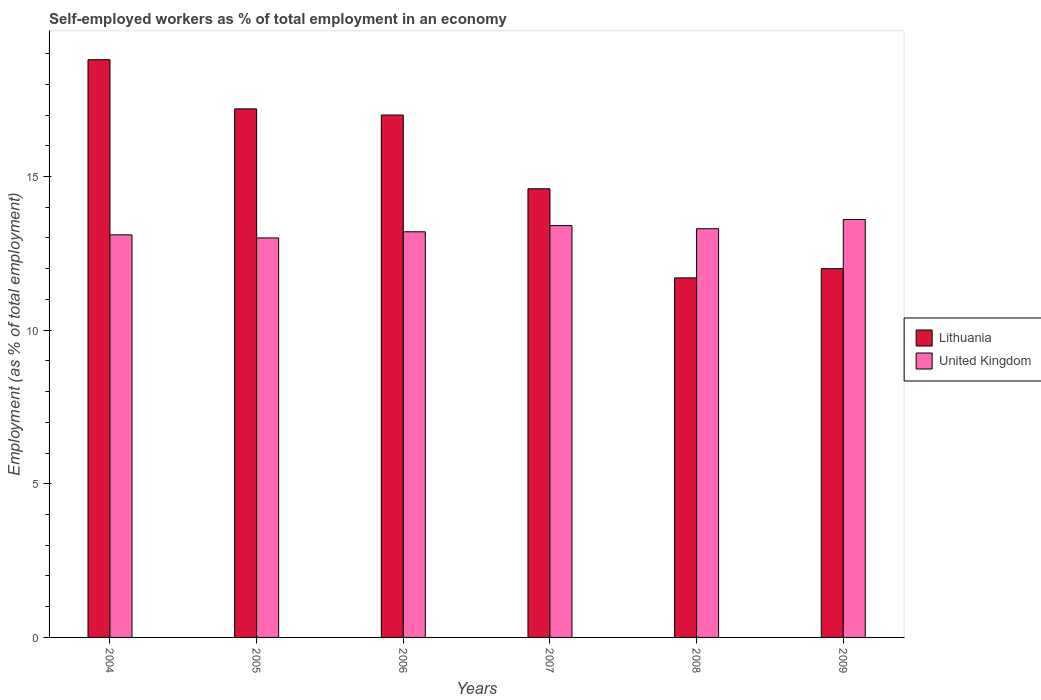How many different coloured bars are there?
Your answer should be compact. 2. How many groups of bars are there?
Offer a terse response. 6. Are the number of bars per tick equal to the number of legend labels?
Your response must be concise. Yes. Are the number of bars on each tick of the X-axis equal?
Offer a terse response. Yes. How many bars are there on the 4th tick from the right?
Your answer should be very brief. 2. What is the label of the 2nd group of bars from the left?
Keep it short and to the point. 2005. In how many cases, is the number of bars for a given year not equal to the number of legend labels?
Provide a short and direct response. 0. What is the percentage of self-employed workers in United Kingdom in 2005?
Ensure brevity in your answer.  13. Across all years, what is the maximum percentage of self-employed workers in Lithuania?
Give a very brief answer. 18.8. Across all years, what is the minimum percentage of self-employed workers in Lithuania?
Your response must be concise. 11.7. In which year was the percentage of self-employed workers in Lithuania maximum?
Give a very brief answer. 2004. What is the total percentage of self-employed workers in Lithuania in the graph?
Offer a very short reply. 91.3. What is the difference between the percentage of self-employed workers in Lithuania in 2005 and that in 2008?
Make the answer very short. 5.5. What is the difference between the percentage of self-employed workers in Lithuania in 2006 and the percentage of self-employed workers in United Kingdom in 2004?
Your answer should be compact. 3.9. What is the average percentage of self-employed workers in Lithuania per year?
Offer a very short reply. 15.22. In the year 2006, what is the difference between the percentage of self-employed workers in Lithuania and percentage of self-employed workers in United Kingdom?
Make the answer very short. 3.8. What is the ratio of the percentage of self-employed workers in Lithuania in 2004 to that in 2007?
Provide a short and direct response. 1.29. What is the difference between the highest and the second highest percentage of self-employed workers in Lithuania?
Offer a terse response. 1.6. What is the difference between the highest and the lowest percentage of self-employed workers in United Kingdom?
Provide a succinct answer. 0.6. In how many years, is the percentage of self-employed workers in United Kingdom greater than the average percentage of self-employed workers in United Kingdom taken over all years?
Your answer should be compact. 3. What does the 1st bar from the left in 2008 represents?
Your answer should be compact. Lithuania. What does the 1st bar from the right in 2009 represents?
Keep it short and to the point. United Kingdom. How many bars are there?
Offer a terse response. 12. Are the values on the major ticks of Y-axis written in scientific E-notation?
Provide a succinct answer. No. Does the graph contain any zero values?
Provide a succinct answer. No. How many legend labels are there?
Offer a terse response. 2. How are the legend labels stacked?
Offer a very short reply. Vertical. What is the title of the graph?
Make the answer very short. Self-employed workers as % of total employment in an economy. What is the label or title of the X-axis?
Offer a very short reply. Years. What is the label or title of the Y-axis?
Ensure brevity in your answer.  Employment (as % of total employment). What is the Employment (as % of total employment) of Lithuania in 2004?
Your answer should be very brief. 18.8. What is the Employment (as % of total employment) in United Kingdom in 2004?
Make the answer very short. 13.1. What is the Employment (as % of total employment) of Lithuania in 2005?
Make the answer very short. 17.2. What is the Employment (as % of total employment) in United Kingdom in 2005?
Keep it short and to the point. 13. What is the Employment (as % of total employment) in United Kingdom in 2006?
Your answer should be very brief. 13.2. What is the Employment (as % of total employment) in Lithuania in 2007?
Give a very brief answer. 14.6. What is the Employment (as % of total employment) of United Kingdom in 2007?
Offer a terse response. 13.4. What is the Employment (as % of total employment) in Lithuania in 2008?
Offer a very short reply. 11.7. What is the Employment (as % of total employment) in United Kingdom in 2008?
Your response must be concise. 13.3. What is the Employment (as % of total employment) of United Kingdom in 2009?
Your answer should be compact. 13.6. Across all years, what is the maximum Employment (as % of total employment) of Lithuania?
Offer a terse response. 18.8. Across all years, what is the maximum Employment (as % of total employment) in United Kingdom?
Offer a terse response. 13.6. Across all years, what is the minimum Employment (as % of total employment) in Lithuania?
Provide a succinct answer. 11.7. Across all years, what is the minimum Employment (as % of total employment) of United Kingdom?
Offer a terse response. 13. What is the total Employment (as % of total employment) in Lithuania in the graph?
Offer a very short reply. 91.3. What is the total Employment (as % of total employment) in United Kingdom in the graph?
Your response must be concise. 79.6. What is the difference between the Employment (as % of total employment) in United Kingdom in 2004 and that in 2005?
Provide a succinct answer. 0.1. What is the difference between the Employment (as % of total employment) in United Kingdom in 2004 and that in 2006?
Your answer should be very brief. -0.1. What is the difference between the Employment (as % of total employment) of United Kingdom in 2004 and that in 2007?
Provide a short and direct response. -0.3. What is the difference between the Employment (as % of total employment) of United Kingdom in 2004 and that in 2009?
Provide a succinct answer. -0.5. What is the difference between the Employment (as % of total employment) in Lithuania in 2005 and that in 2006?
Offer a very short reply. 0.2. What is the difference between the Employment (as % of total employment) in Lithuania in 2005 and that in 2007?
Make the answer very short. 2.6. What is the difference between the Employment (as % of total employment) of United Kingdom in 2005 and that in 2007?
Provide a succinct answer. -0.4. What is the difference between the Employment (as % of total employment) of United Kingdom in 2005 and that in 2008?
Offer a very short reply. -0.3. What is the difference between the Employment (as % of total employment) of United Kingdom in 2005 and that in 2009?
Offer a terse response. -0.6. What is the difference between the Employment (as % of total employment) in Lithuania in 2006 and that in 2007?
Keep it short and to the point. 2.4. What is the difference between the Employment (as % of total employment) of Lithuania in 2006 and that in 2009?
Your answer should be very brief. 5. What is the difference between the Employment (as % of total employment) of United Kingdom in 2006 and that in 2009?
Offer a very short reply. -0.4. What is the difference between the Employment (as % of total employment) in Lithuania in 2007 and that in 2008?
Provide a short and direct response. 2.9. What is the difference between the Employment (as % of total employment) in United Kingdom in 2007 and that in 2008?
Offer a terse response. 0.1. What is the difference between the Employment (as % of total employment) in United Kingdom in 2007 and that in 2009?
Keep it short and to the point. -0.2. What is the difference between the Employment (as % of total employment) in Lithuania in 2008 and that in 2009?
Make the answer very short. -0.3. What is the difference between the Employment (as % of total employment) of United Kingdom in 2008 and that in 2009?
Your response must be concise. -0.3. What is the difference between the Employment (as % of total employment) in Lithuania in 2004 and the Employment (as % of total employment) in United Kingdom in 2005?
Make the answer very short. 5.8. What is the difference between the Employment (as % of total employment) of Lithuania in 2004 and the Employment (as % of total employment) of United Kingdom in 2006?
Offer a very short reply. 5.6. What is the difference between the Employment (as % of total employment) of Lithuania in 2004 and the Employment (as % of total employment) of United Kingdom in 2007?
Your answer should be very brief. 5.4. What is the difference between the Employment (as % of total employment) in Lithuania in 2004 and the Employment (as % of total employment) in United Kingdom in 2008?
Offer a very short reply. 5.5. What is the difference between the Employment (as % of total employment) in Lithuania in 2005 and the Employment (as % of total employment) in United Kingdom in 2006?
Provide a succinct answer. 4. What is the difference between the Employment (as % of total employment) of Lithuania in 2005 and the Employment (as % of total employment) of United Kingdom in 2009?
Ensure brevity in your answer.  3.6. What is the difference between the Employment (as % of total employment) in Lithuania in 2006 and the Employment (as % of total employment) in United Kingdom in 2008?
Make the answer very short. 3.7. What is the difference between the Employment (as % of total employment) of Lithuania in 2008 and the Employment (as % of total employment) of United Kingdom in 2009?
Make the answer very short. -1.9. What is the average Employment (as % of total employment) in Lithuania per year?
Your answer should be very brief. 15.22. What is the average Employment (as % of total employment) of United Kingdom per year?
Your answer should be compact. 13.27. In the year 2004, what is the difference between the Employment (as % of total employment) in Lithuania and Employment (as % of total employment) in United Kingdom?
Give a very brief answer. 5.7. In the year 2005, what is the difference between the Employment (as % of total employment) of Lithuania and Employment (as % of total employment) of United Kingdom?
Ensure brevity in your answer.  4.2. In the year 2006, what is the difference between the Employment (as % of total employment) in Lithuania and Employment (as % of total employment) in United Kingdom?
Your answer should be compact. 3.8. In the year 2008, what is the difference between the Employment (as % of total employment) in Lithuania and Employment (as % of total employment) in United Kingdom?
Your answer should be compact. -1.6. In the year 2009, what is the difference between the Employment (as % of total employment) of Lithuania and Employment (as % of total employment) of United Kingdom?
Your response must be concise. -1.6. What is the ratio of the Employment (as % of total employment) in Lithuania in 2004 to that in 2005?
Give a very brief answer. 1.09. What is the ratio of the Employment (as % of total employment) of United Kingdom in 2004 to that in 2005?
Provide a short and direct response. 1.01. What is the ratio of the Employment (as % of total employment) of Lithuania in 2004 to that in 2006?
Give a very brief answer. 1.11. What is the ratio of the Employment (as % of total employment) of United Kingdom in 2004 to that in 2006?
Provide a short and direct response. 0.99. What is the ratio of the Employment (as % of total employment) in Lithuania in 2004 to that in 2007?
Your response must be concise. 1.29. What is the ratio of the Employment (as % of total employment) of United Kingdom in 2004 to that in 2007?
Provide a succinct answer. 0.98. What is the ratio of the Employment (as % of total employment) in Lithuania in 2004 to that in 2008?
Provide a succinct answer. 1.61. What is the ratio of the Employment (as % of total employment) in Lithuania in 2004 to that in 2009?
Give a very brief answer. 1.57. What is the ratio of the Employment (as % of total employment) of United Kingdom in 2004 to that in 2009?
Keep it short and to the point. 0.96. What is the ratio of the Employment (as % of total employment) in Lithuania in 2005 to that in 2006?
Offer a very short reply. 1.01. What is the ratio of the Employment (as % of total employment) of United Kingdom in 2005 to that in 2006?
Your answer should be compact. 0.98. What is the ratio of the Employment (as % of total employment) in Lithuania in 2005 to that in 2007?
Offer a terse response. 1.18. What is the ratio of the Employment (as % of total employment) of United Kingdom in 2005 to that in 2007?
Offer a very short reply. 0.97. What is the ratio of the Employment (as % of total employment) of Lithuania in 2005 to that in 2008?
Offer a terse response. 1.47. What is the ratio of the Employment (as % of total employment) in United Kingdom in 2005 to that in 2008?
Keep it short and to the point. 0.98. What is the ratio of the Employment (as % of total employment) in Lithuania in 2005 to that in 2009?
Make the answer very short. 1.43. What is the ratio of the Employment (as % of total employment) of United Kingdom in 2005 to that in 2009?
Offer a very short reply. 0.96. What is the ratio of the Employment (as % of total employment) of Lithuania in 2006 to that in 2007?
Your response must be concise. 1.16. What is the ratio of the Employment (as % of total employment) of United Kingdom in 2006 to that in 2007?
Your answer should be compact. 0.99. What is the ratio of the Employment (as % of total employment) in Lithuania in 2006 to that in 2008?
Your response must be concise. 1.45. What is the ratio of the Employment (as % of total employment) of Lithuania in 2006 to that in 2009?
Keep it short and to the point. 1.42. What is the ratio of the Employment (as % of total employment) in United Kingdom in 2006 to that in 2009?
Provide a short and direct response. 0.97. What is the ratio of the Employment (as % of total employment) in Lithuania in 2007 to that in 2008?
Your response must be concise. 1.25. What is the ratio of the Employment (as % of total employment) of United Kingdom in 2007 to that in 2008?
Offer a very short reply. 1.01. What is the ratio of the Employment (as % of total employment) in Lithuania in 2007 to that in 2009?
Make the answer very short. 1.22. What is the ratio of the Employment (as % of total employment) of United Kingdom in 2007 to that in 2009?
Your response must be concise. 0.99. What is the ratio of the Employment (as % of total employment) of Lithuania in 2008 to that in 2009?
Keep it short and to the point. 0.97. What is the ratio of the Employment (as % of total employment) of United Kingdom in 2008 to that in 2009?
Keep it short and to the point. 0.98. What is the difference between the highest and the second highest Employment (as % of total employment) in United Kingdom?
Your answer should be very brief. 0.2. What is the difference between the highest and the lowest Employment (as % of total employment) of United Kingdom?
Provide a succinct answer. 0.6. 